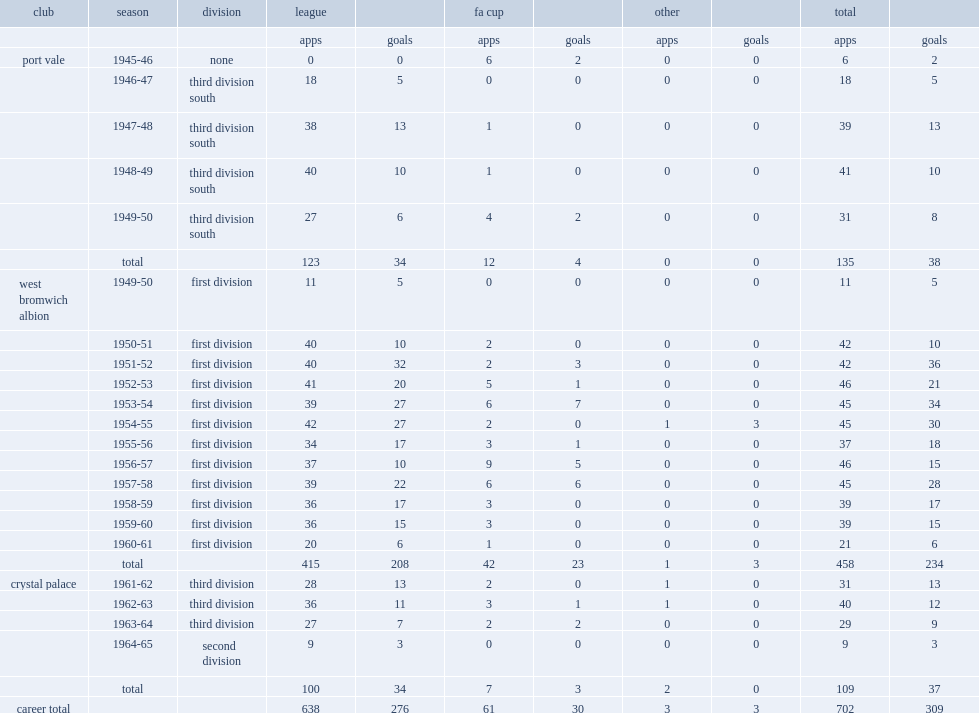How many appearances did ronnie allen make for west brom in total? 458.0. 